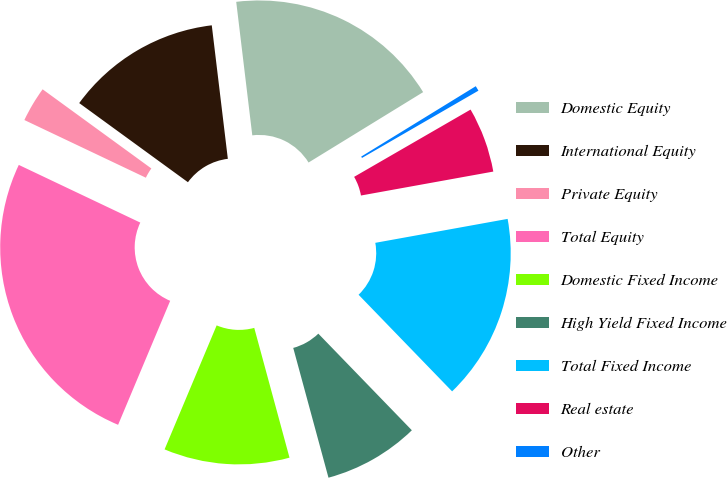Convert chart to OTSL. <chart><loc_0><loc_0><loc_500><loc_500><pie_chart><fcel>Domestic Equity<fcel>International Equity<fcel>Private Equity<fcel>Total Equity<fcel>Domestic Fixed Income<fcel>High Yield Fixed Income<fcel>Total Fixed Income<fcel>Real estate<fcel>Other<nl><fcel>18.14%<fcel>13.08%<fcel>2.96%<fcel>25.73%<fcel>10.55%<fcel>8.02%<fcel>15.61%<fcel>5.49%<fcel>0.43%<nl></chart> 